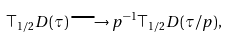Convert formula to latex. <formula><loc_0><loc_0><loc_500><loc_500>\top _ { 1 / 2 } D ( \tau ) \longrightarrow p ^ { - 1 } \top _ { 1 / 2 } D ( \tau / p ) ,</formula> 